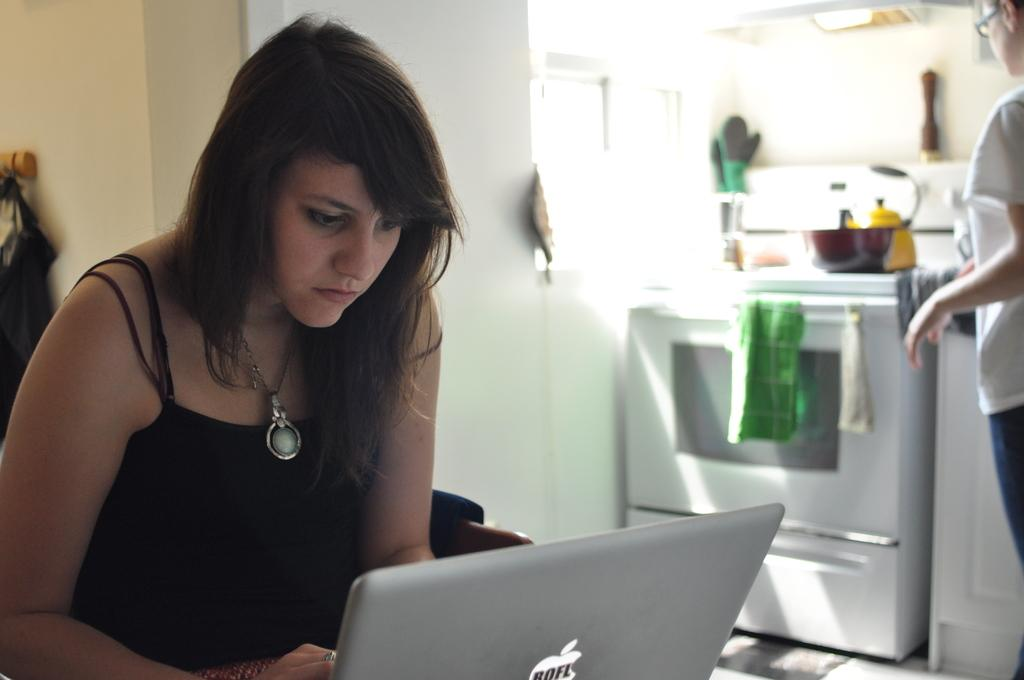<image>
Relay a brief, clear account of the picture shown. A woman on a laptop with a sticker that says 'ROFL'. 